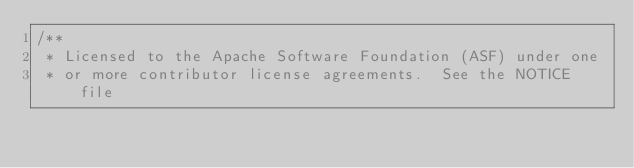Convert code to text. <code><loc_0><loc_0><loc_500><loc_500><_Java_>/**
 * Licensed to the Apache Software Foundation (ASF) under one
 * or more contributor license agreements.  See the NOTICE file</code> 